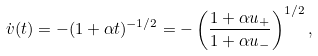<formula> <loc_0><loc_0><loc_500><loc_500>\dot { v } ( t ) = - ( 1 + \alpha t ) ^ { - 1 / 2 } = - \left ( { \frac { 1 + \alpha u _ { + } } { 1 + \alpha u _ { - } } } \right ) ^ { 1 / 2 } ,</formula> 